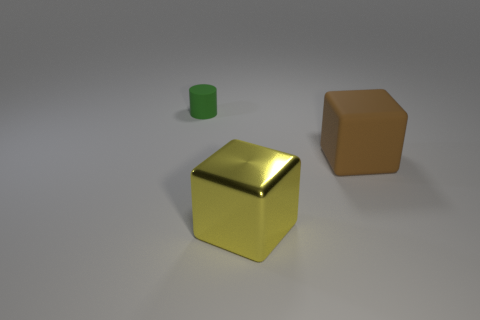There is a shiny object that is the same size as the brown matte object; what color is it?
Offer a terse response. Yellow. Is the color of the big matte cube the same as the matte object that is on the left side of the big yellow metallic thing?
Your answer should be very brief. No. What color is the tiny cylinder?
Make the answer very short. Green. What is the material of the large thing on the left side of the big brown block?
Give a very brief answer. Metal. Are there fewer tiny green rubber objects that are in front of the green thing than small cyan shiny cubes?
Provide a succinct answer. No. Are there any small brown rubber things?
Your response must be concise. No. What color is the matte thing that is the same shape as the yellow metal thing?
Your answer should be compact. Brown. Do the rubber cube and the matte cylinder have the same size?
Ensure brevity in your answer.  No. There is a tiny green thing that is the same material as the brown cube; what shape is it?
Make the answer very short. Cylinder. What number of other objects are there of the same shape as the small green thing?
Provide a short and direct response. 0. 